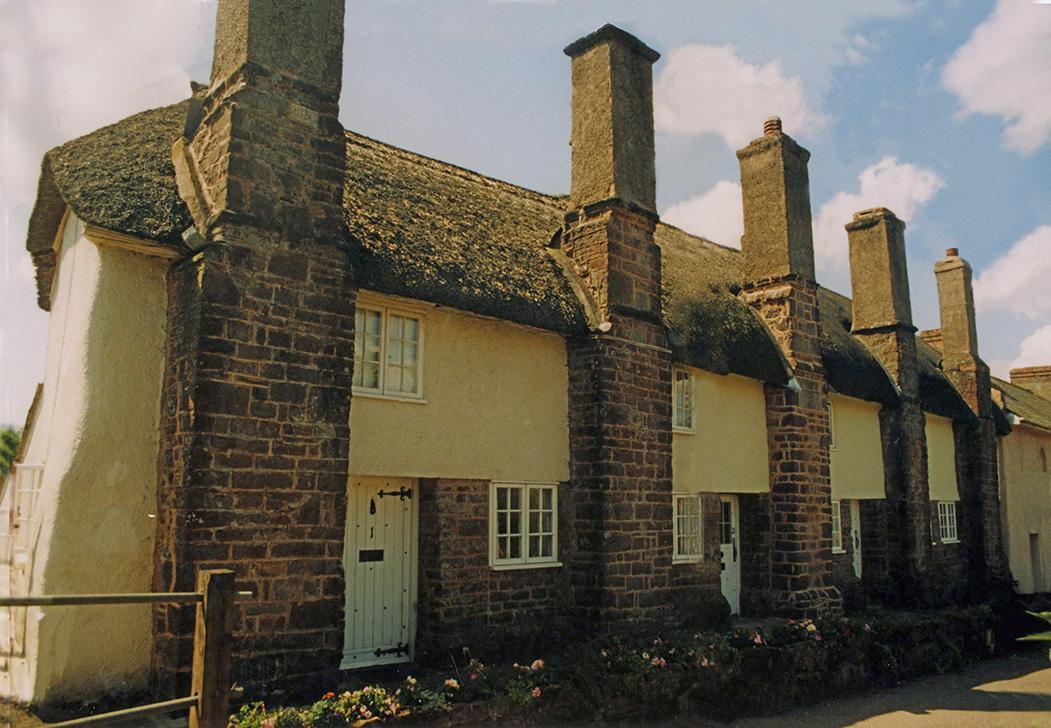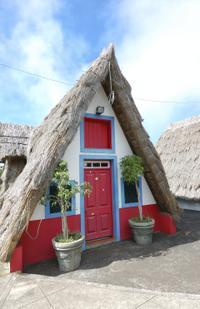The first image is the image on the left, the second image is the image on the right. Evaluate the accuracy of this statement regarding the images: "The right image shows the peaked front of a building with a thatched roof that curves around at least one dormer window extending out of the upper front of the house.". Is it true? Answer yes or no. No. The first image is the image on the left, the second image is the image on the right. Examine the images to the left and right. Is the description "A road is seen to the left of the building in one image and not in the other." accurate? Answer yes or no. No. 